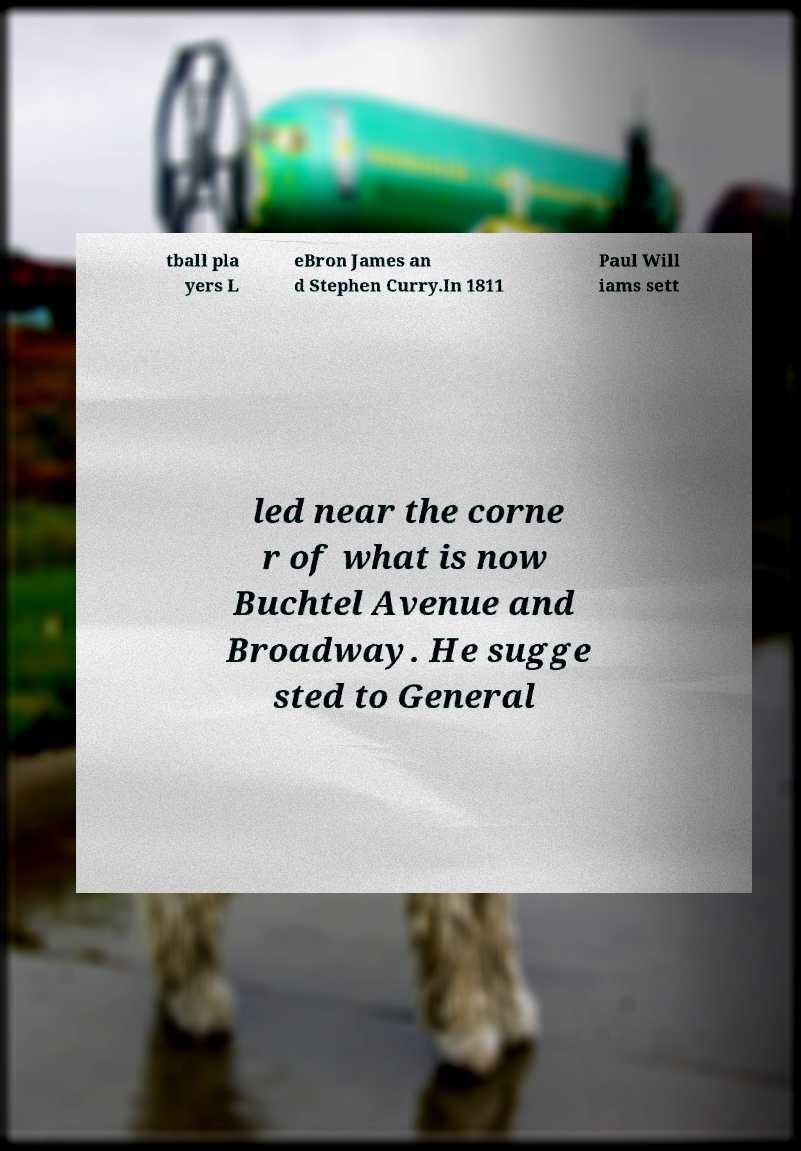Could you assist in decoding the text presented in this image and type it out clearly? tball pla yers L eBron James an d Stephen Curry.In 1811 Paul Will iams sett led near the corne r of what is now Buchtel Avenue and Broadway. He sugge sted to General 